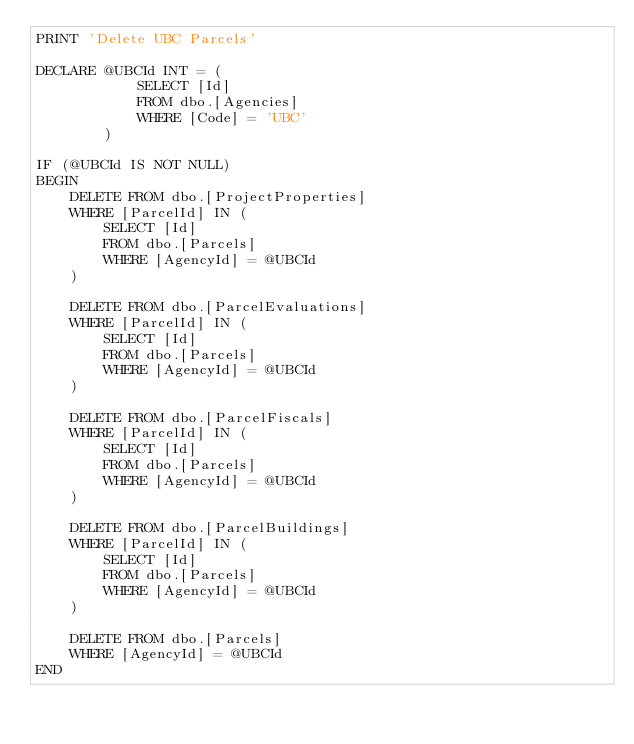<code> <loc_0><loc_0><loc_500><loc_500><_SQL_>PRINT 'Delete UBC Parcels'

DECLARE @UBCId INT = (
            SELECT [Id]
            FROM dbo.[Agencies]
            WHERE [Code] = 'UBC'
        )

IF (@UBCId IS NOT NULL)
BEGIN
    DELETE FROM dbo.[ProjectProperties]
    WHERE [ParcelId] IN (
        SELECT [Id]
        FROM dbo.[Parcels]
        WHERE [AgencyId] = @UBCId
    )

    DELETE FROM dbo.[ParcelEvaluations]
    WHERE [ParcelId] IN (
        SELECT [Id]
        FROM dbo.[Parcels]
        WHERE [AgencyId] = @UBCId
    )

    DELETE FROM dbo.[ParcelFiscals]
    WHERE [ParcelId] IN (
        SELECT [Id]
        FROM dbo.[Parcels]
        WHERE [AgencyId] = @UBCId
    )

    DELETE FROM dbo.[ParcelBuildings]
    WHERE [ParcelId] IN (
        SELECT [Id]
        FROM dbo.[Parcels]
        WHERE [AgencyId] = @UBCId
    )

    DELETE FROM dbo.[Parcels]
    WHERE [AgencyId] = @UBCId
END
</code> 